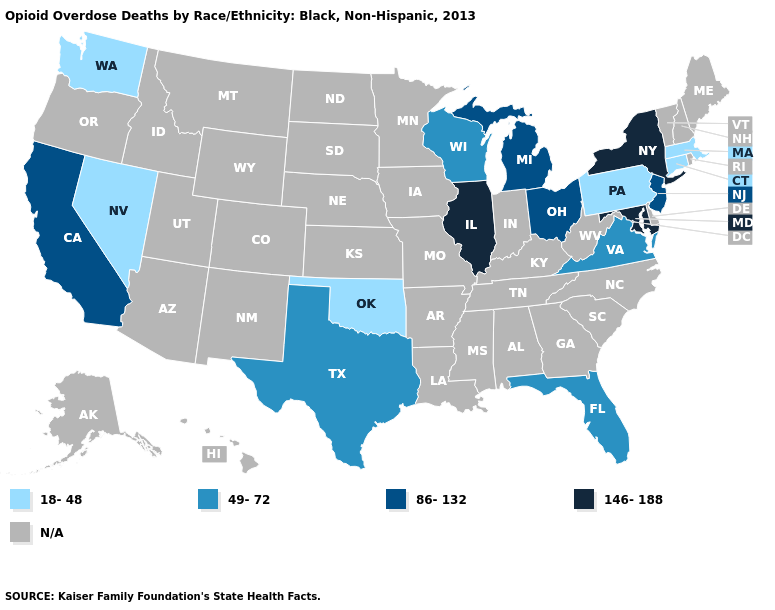What is the value of New Jersey?
Give a very brief answer. 86-132. Does the first symbol in the legend represent the smallest category?
Write a very short answer. Yes. Does the map have missing data?
Short answer required. Yes. Which states have the highest value in the USA?
Concise answer only. Illinois, Maryland, New York. What is the value of Delaware?
Keep it brief. N/A. What is the value of Idaho?
Be succinct. N/A. Which states hav the highest value in the West?
Concise answer only. California. Among the states that border New Jersey , which have the highest value?
Write a very short answer. New York. What is the value of Maine?
Quick response, please. N/A. What is the lowest value in states that border Texas?
Be succinct. 18-48. Name the states that have a value in the range 18-48?
Keep it brief. Connecticut, Massachusetts, Nevada, Oklahoma, Pennsylvania, Washington. Is the legend a continuous bar?
Be succinct. No. What is the lowest value in states that border Virginia?
Give a very brief answer. 146-188. 